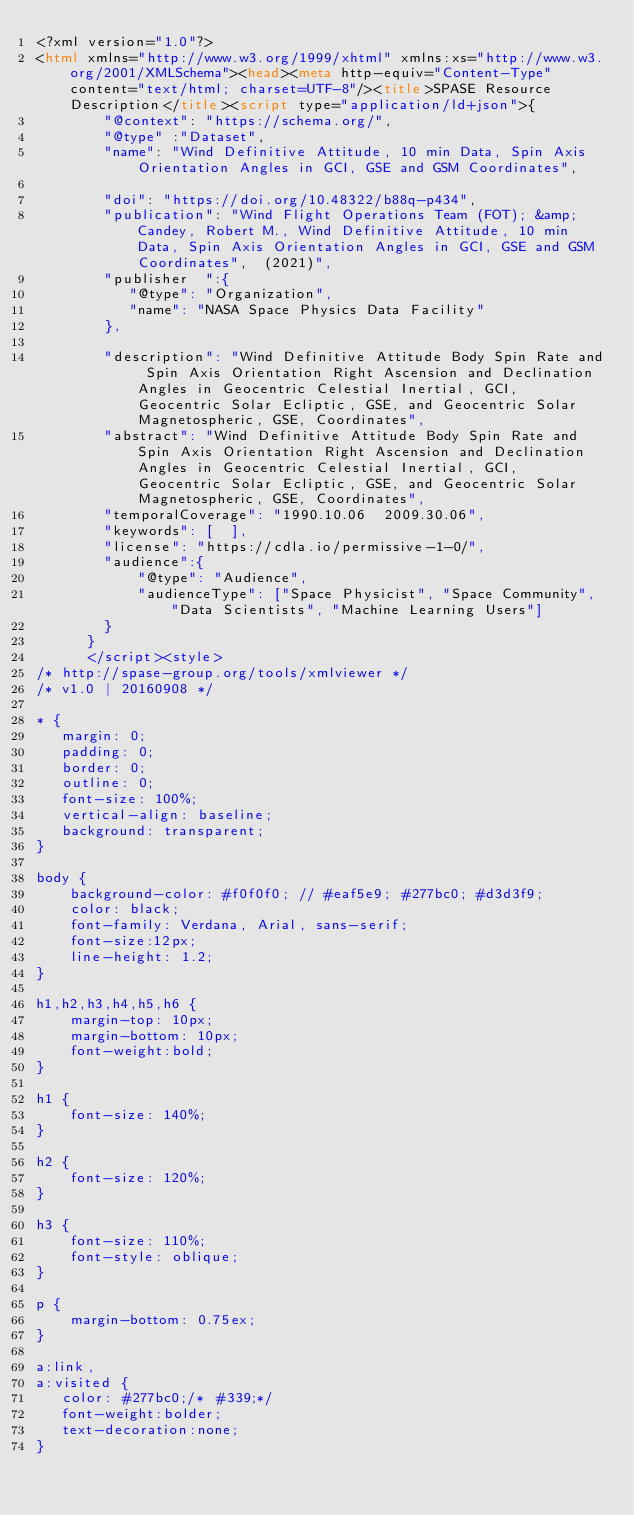Convert code to text. <code><loc_0><loc_0><loc_500><loc_500><_HTML_><?xml version="1.0"?>
<html xmlns="http://www.w3.org/1999/xhtml" xmlns:xs="http://www.w3.org/2001/XMLSchema"><head><meta http-equiv="Content-Type" content="text/html; charset=UTF-8"/><title>SPASE Resource Description</title><script type="application/ld+json">{
		"@context": "https://schema.org/",
		"@type" :"Dataset",
		"name": "Wind Definitive Attitude, 10 min Data, Spin Axis Orientation Angles in GCI, GSE and GSM Coordinates",
     
		"doi": "https://doi.org/10.48322/b88q-p434",
		"publication": "Wind Flight Operations Team (FOT); &amp; Candey, Robert M., Wind Definitive Attitude, 10 min Data, Spin Axis Orientation Angles in GCI, GSE and GSM Coordinates",  (2021)",
		"publisher  ":{
		   "@type": "Organization",
           "name": "NASA Space Physics Data Facility"
		},
	
 		"description": "Wind Definitive Attitude Body Spin Rate and Spin Axis Orientation Right Ascension and Declination Angles in Geocentric Celestial Inertial, GCI, Geocentric Solar Ecliptic, GSE, and Geocentric Solar Magnetospheric, GSE, Coordinates",
		"abstract": "Wind Definitive Attitude Body Spin Rate and Spin Axis Orientation Right Ascension and Declination Angles in Geocentric Celestial Inertial, GCI, Geocentric Solar Ecliptic, GSE, and Geocentric Solar Magnetospheric, GSE, Coordinates",
		"temporalCoverage": "1990.10.06  2009.30.06",
		"keywords": [  ],
		"license": "https://cdla.io/permissive-1-0/",
        "audience":{
            "@type": "Audience",
            "audienceType": ["Space Physicist", "Space Community", "Data Scientists", "Machine Learning Users"]
        }
	  }
	  </script><style>
/* http://spase-group.org/tools/xmlviewer */
/* v1.0 | 20160908 */

* {
   margin: 0;
   padding: 0;
   border: 0;
   outline: 0;
   font-size: 100%;
   vertical-align: baseline;
   background: transparent;
}

body {
	background-color: #f0f0f0; // #eaf5e9; #277bc0; #d3d3f9;
	color: black;
	font-family: Verdana, Arial, sans-serif; 
	font-size:12px; 
	line-height: 1.2;
}
 
h1,h2,h3,h4,h5,h6 {
	margin-top: 10px;
	margin-bottom: 10px;
	font-weight:bold;
}

h1 {
	font-size: 140%;
}

h2 {
	font-size: 120%;
}

h3 {
	font-size: 110%;
	font-style: oblique;
}

p {
	margin-bottom: 0.75ex;
}

a:link,
a:visited {
   color: #277bc0;/* #339;*/
   font-weight:bolder; 
   text-decoration:none; 
}
</code> 